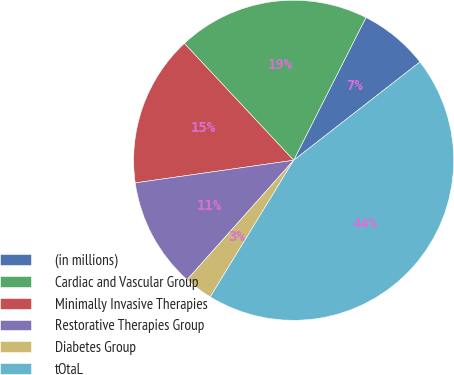Convert chart to OTSL. <chart><loc_0><loc_0><loc_500><loc_500><pie_chart><fcel>(in millions)<fcel>Cardiac and Vascular Group<fcel>Minimally Invasive Therapies<fcel>Restorative Therapies Group<fcel>Diabetes Group<fcel>tOtaL<nl><fcel>7.01%<fcel>19.43%<fcel>15.29%<fcel>11.15%<fcel>2.87%<fcel>44.26%<nl></chart> 